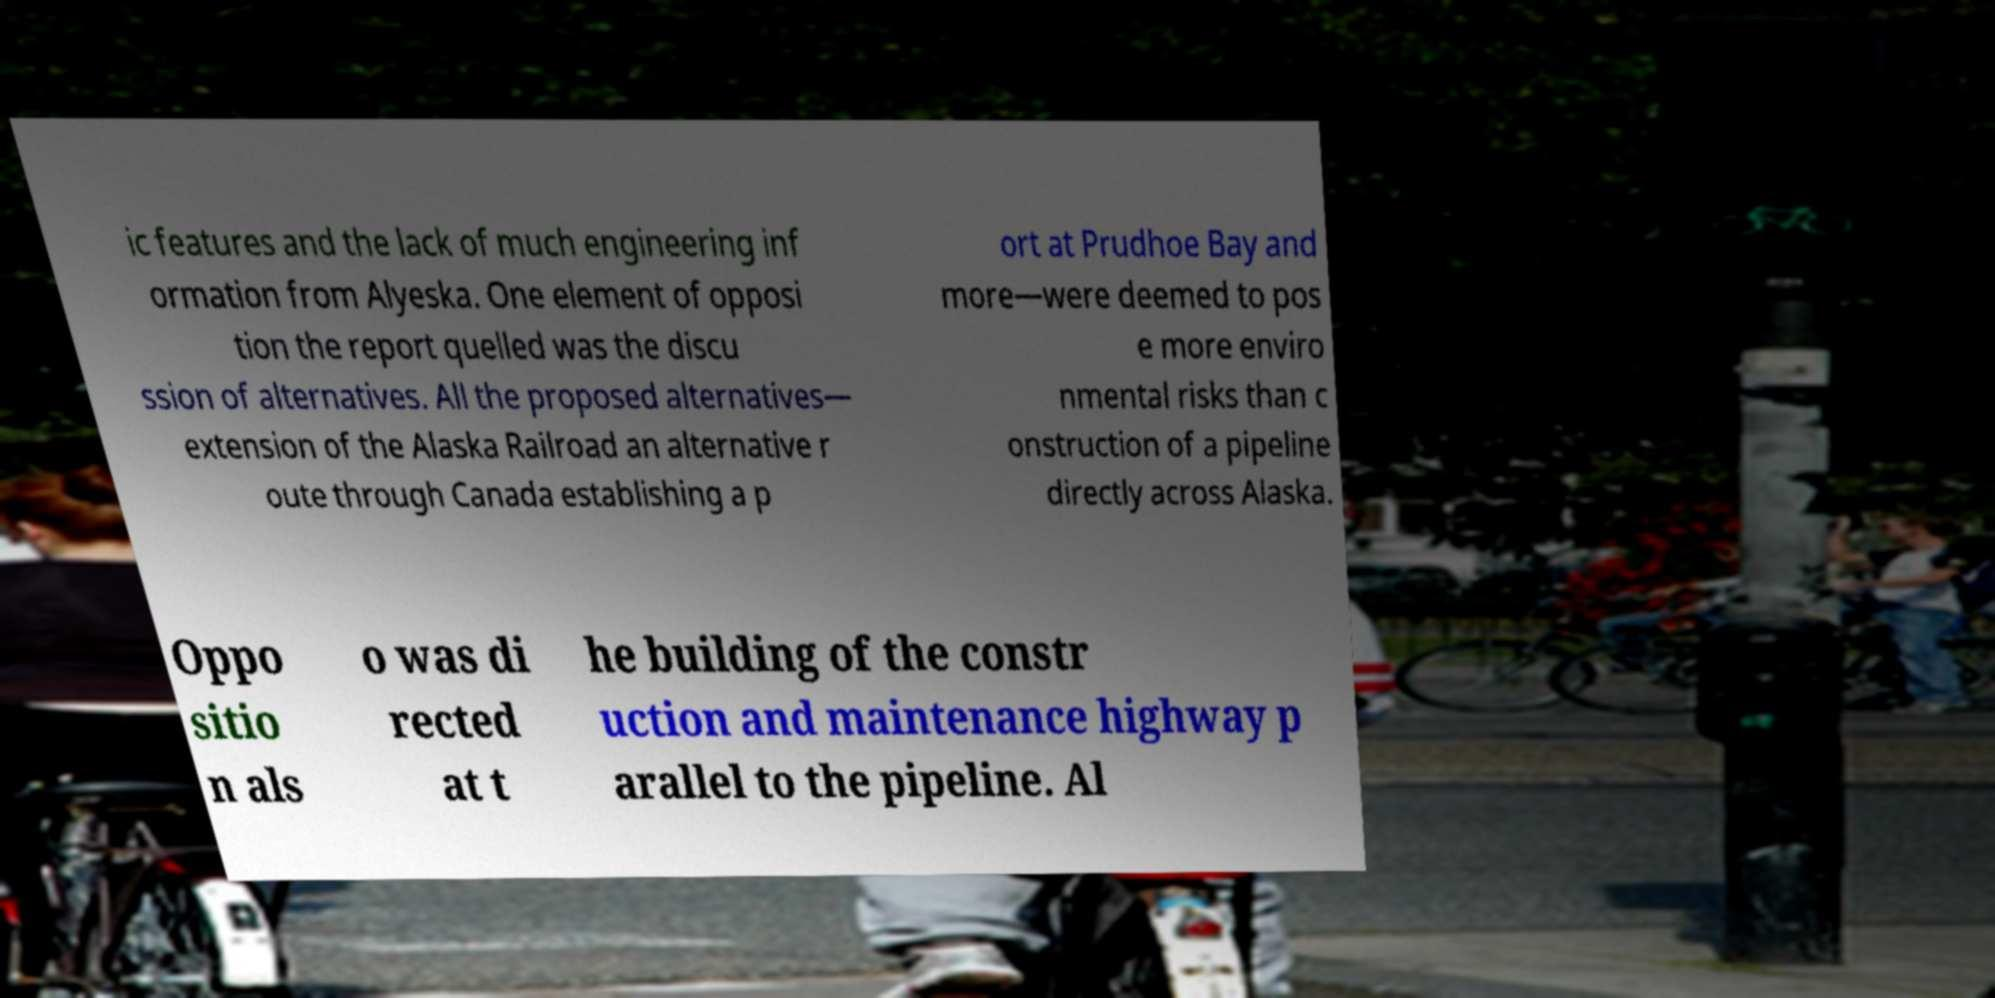Can you read and provide the text displayed in the image?This photo seems to have some interesting text. Can you extract and type it out for me? ic features and the lack of much engineering inf ormation from Alyeska. One element of opposi tion the report quelled was the discu ssion of alternatives. All the proposed alternatives— extension of the Alaska Railroad an alternative r oute through Canada establishing a p ort at Prudhoe Bay and more—were deemed to pos e more enviro nmental risks than c onstruction of a pipeline directly across Alaska. Oppo sitio n als o was di rected at t he building of the constr uction and maintenance highway p arallel to the pipeline. Al 